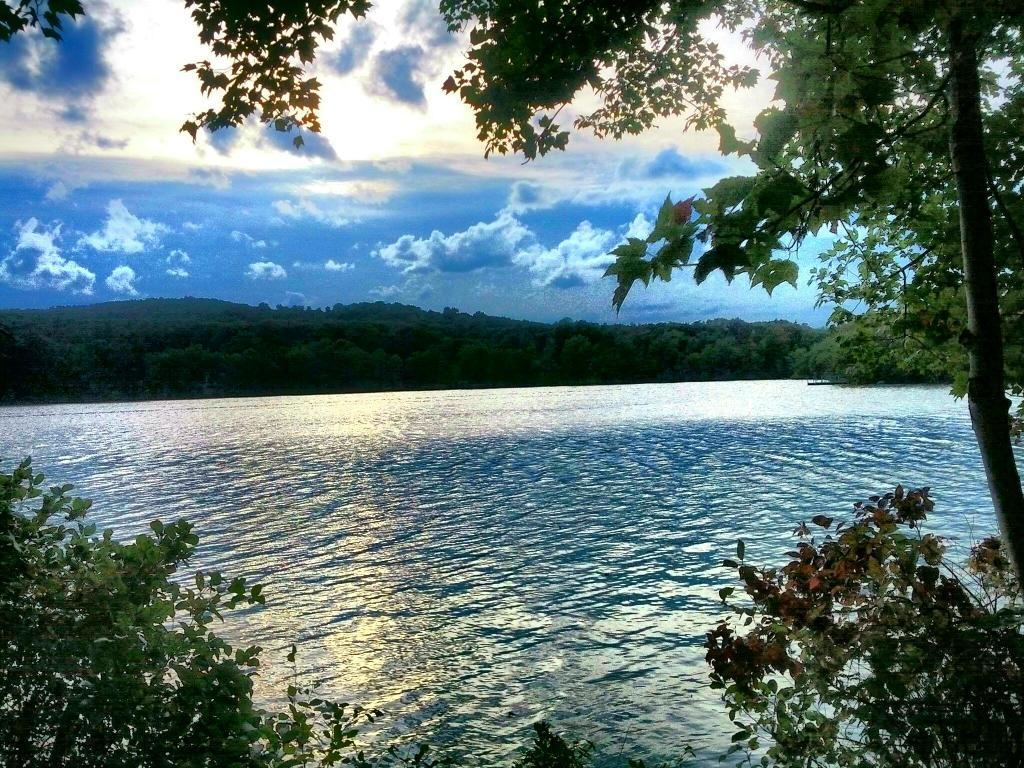What type of vegetation can be seen in the image? There are trees in the image. What natural element is visible besides the trees? There is water visible in the image. What can be seen in the sky in the image? There are clouds in the image. What type of nut is being used as an apparatus in the image? There is no nut or apparatus present in the image; it features trees, water, and clouds. 